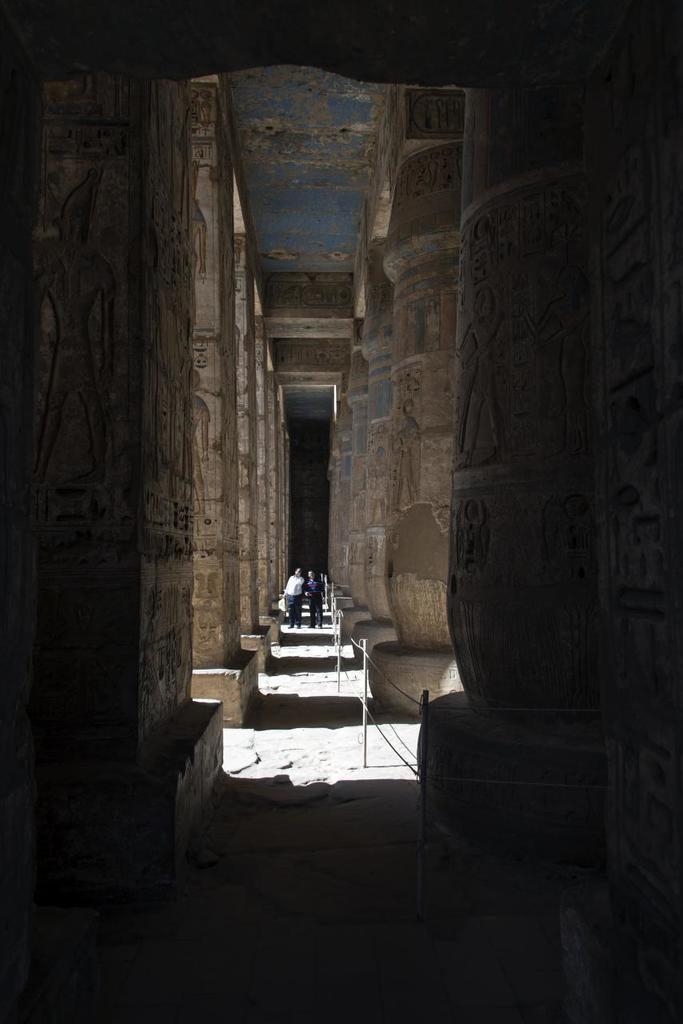Describe this image in one or two sentences. In this picture we can see many pillars on the right and left side of the path. We can see two people standing on the path. There are carvings visible on these pillars. 